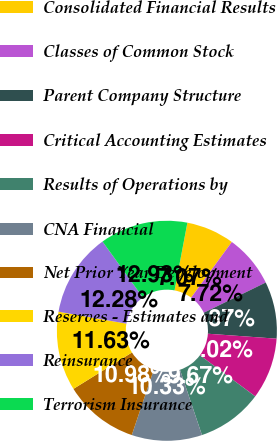<chart> <loc_0><loc_0><loc_500><loc_500><pie_chart><fcel>Consolidated Financial Results<fcel>Classes of Common Stock<fcel>Parent Company Structure<fcel>Critical Accounting Estimates<fcel>Results of Operations by<fcel>CNA Financial<fcel>Net Prior Year Development<fcel>Reserves - Estimates and<fcel>Reinsurance<fcel>Terrorism Insurance<nl><fcel>7.07%<fcel>7.72%<fcel>8.37%<fcel>9.02%<fcel>9.67%<fcel>10.33%<fcel>10.98%<fcel>11.63%<fcel>12.28%<fcel>12.93%<nl></chart> 